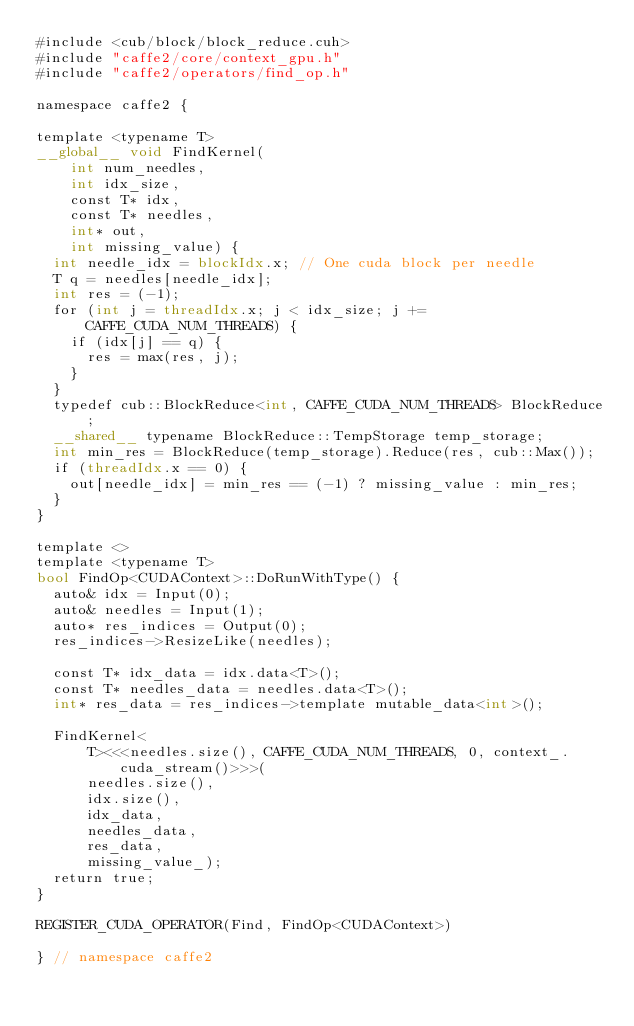Convert code to text. <code><loc_0><loc_0><loc_500><loc_500><_Cuda_>#include <cub/block/block_reduce.cuh>
#include "caffe2/core/context_gpu.h"
#include "caffe2/operators/find_op.h"

namespace caffe2 {

template <typename T>
__global__ void FindKernel(
    int num_needles,
    int idx_size,
    const T* idx,
    const T* needles,
    int* out,
    int missing_value) {
  int needle_idx = blockIdx.x; // One cuda block per needle
  T q = needles[needle_idx];
  int res = (-1);
  for (int j = threadIdx.x; j < idx_size; j += CAFFE_CUDA_NUM_THREADS) {
    if (idx[j] == q) {
      res = max(res, j);
    }
  }
  typedef cub::BlockReduce<int, CAFFE_CUDA_NUM_THREADS> BlockReduce;
  __shared__ typename BlockReduce::TempStorage temp_storage;
  int min_res = BlockReduce(temp_storage).Reduce(res, cub::Max());
  if (threadIdx.x == 0) {
    out[needle_idx] = min_res == (-1) ? missing_value : min_res;
  }
}

template <>
template <typename T>
bool FindOp<CUDAContext>::DoRunWithType() {
  auto& idx = Input(0);
  auto& needles = Input(1);
  auto* res_indices = Output(0);
  res_indices->ResizeLike(needles);

  const T* idx_data = idx.data<T>();
  const T* needles_data = needles.data<T>();
  int* res_data = res_indices->template mutable_data<int>();

  FindKernel<
      T><<<needles.size(), CAFFE_CUDA_NUM_THREADS, 0, context_.cuda_stream()>>>(
      needles.size(),
      idx.size(),
      idx_data,
      needles_data,
      res_data,
      missing_value_);
  return true;
}

REGISTER_CUDA_OPERATOR(Find, FindOp<CUDAContext>)

} // namespace caffe2
</code> 